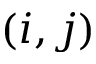<formula> <loc_0><loc_0><loc_500><loc_500>( i , j )</formula> 